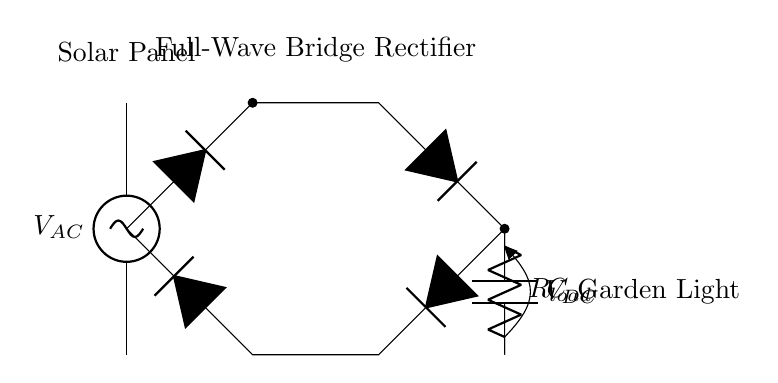What type of power source is used in this circuit? The circuit uses a solar panel as the source of alternating current. It is indicated as the AC source in the diagram.
Answer: solar panel What component converts AC to DC in this circuit? The full-wave bridge rectifier, comprised of four diodes, converts alternating current to direct current. It is labeled in the circuit diagram.
Answer: full-wave bridge rectifier What is the purpose of the capacitor in this circuit? The capacitor smooths out the rectified output voltage, reducing fluctuations in the DC voltage. This is a typical function of a smoothing capacitor in rectifier circuits.
Answer: smoothing What is the load connected to this circuit? The load is a garden light, which is indicated in the circuit diagram next to the load resistor. It consumes the converted DC power for illumination.
Answer: garden light How many diodes are in the bridge rectifier? There are four diodes arranged in the bridge configuration to allow for full-wave rectification. This arrangement is a characteristic of a full-wave bridge rectifier.
Answer: four What is the label for the load resistor in this circuit? The load resistor is labeled R load, showing that it is a component that limits the current flowing to the garden light. It is crucial for protecting the light from excessive current.
Answer: R load 